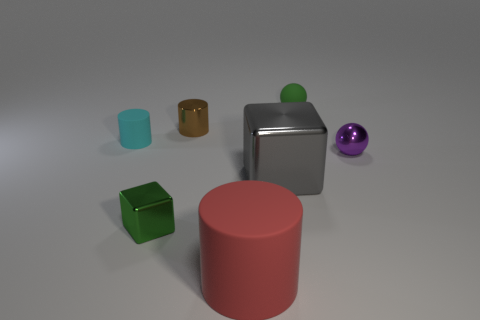Can you tell me what material the green cube is likely made of? The green cube appears to have a smooth and slightly reflective surface, indicating that it could be made of a polished, possibly plastic or painted wooden material. 